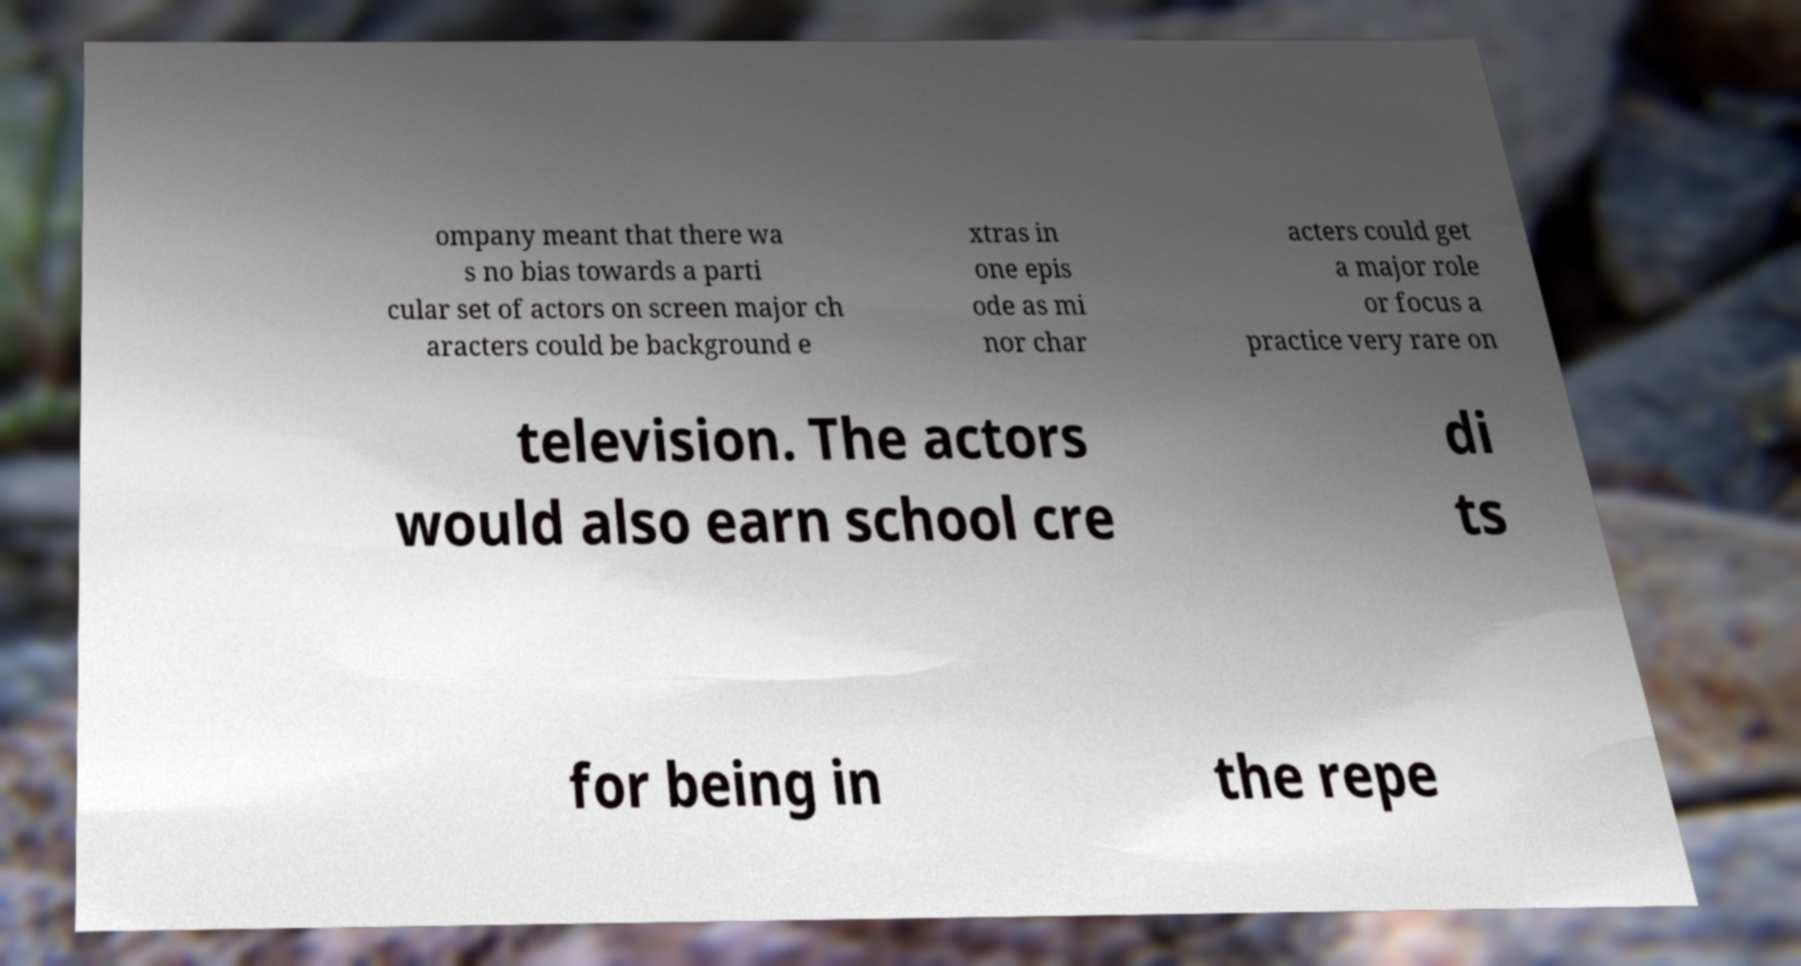Could you assist in decoding the text presented in this image and type it out clearly? ompany meant that there wa s no bias towards a parti cular set of actors on screen major ch aracters could be background e xtras in one epis ode as mi nor char acters could get a major role or focus a practice very rare on television. The actors would also earn school cre di ts for being in the repe 